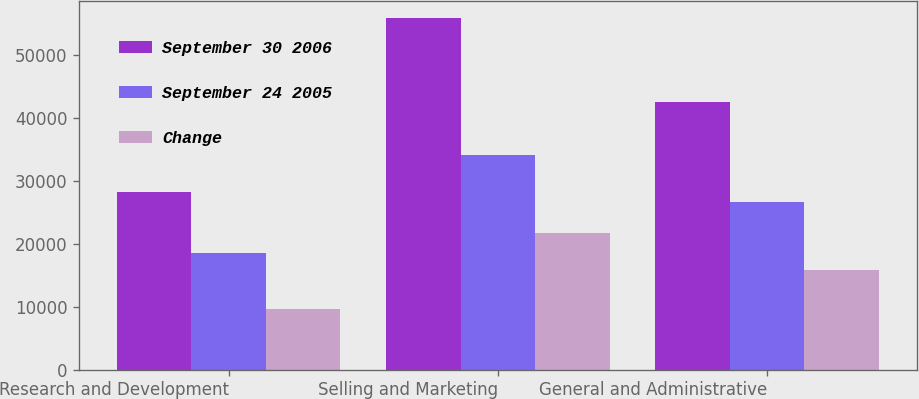Convert chart to OTSL. <chart><loc_0><loc_0><loc_500><loc_500><stacked_bar_chart><ecel><fcel>Research and Development<fcel>Selling and Marketing<fcel>General and Administrative<nl><fcel>September 30 2006<fcel>28294<fcel>55910<fcel>42551<nl><fcel>September 24 2005<fcel>18617<fcel>34199<fcel>26667<nl><fcel>Change<fcel>9677<fcel>21711<fcel>15884<nl></chart> 